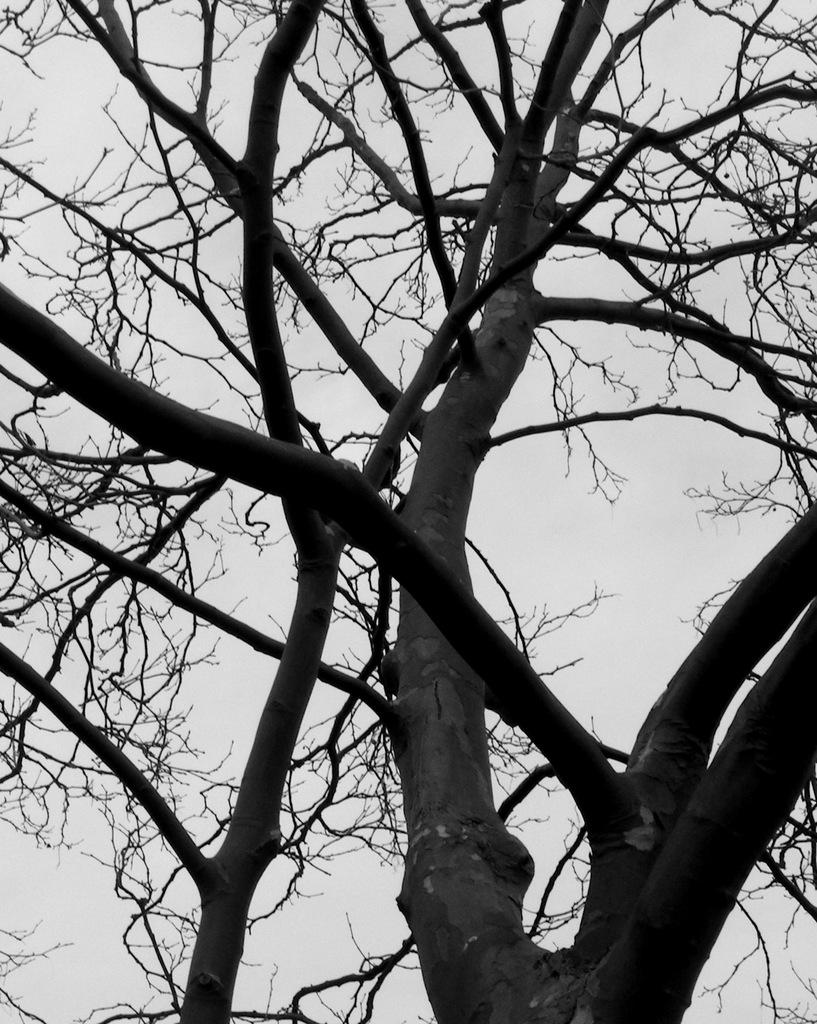What type of natural element can be seen in the image? There is a tree in the image. What is visible at the top of the image? The sky is visible at the top of the image. Where is the amusement park located in the image? There is no amusement park present in the image; it only features a tree and the sky. What type of pot is used to water the tree in the image? There is no pot visible in the image, as it only features a tree and the sky. 